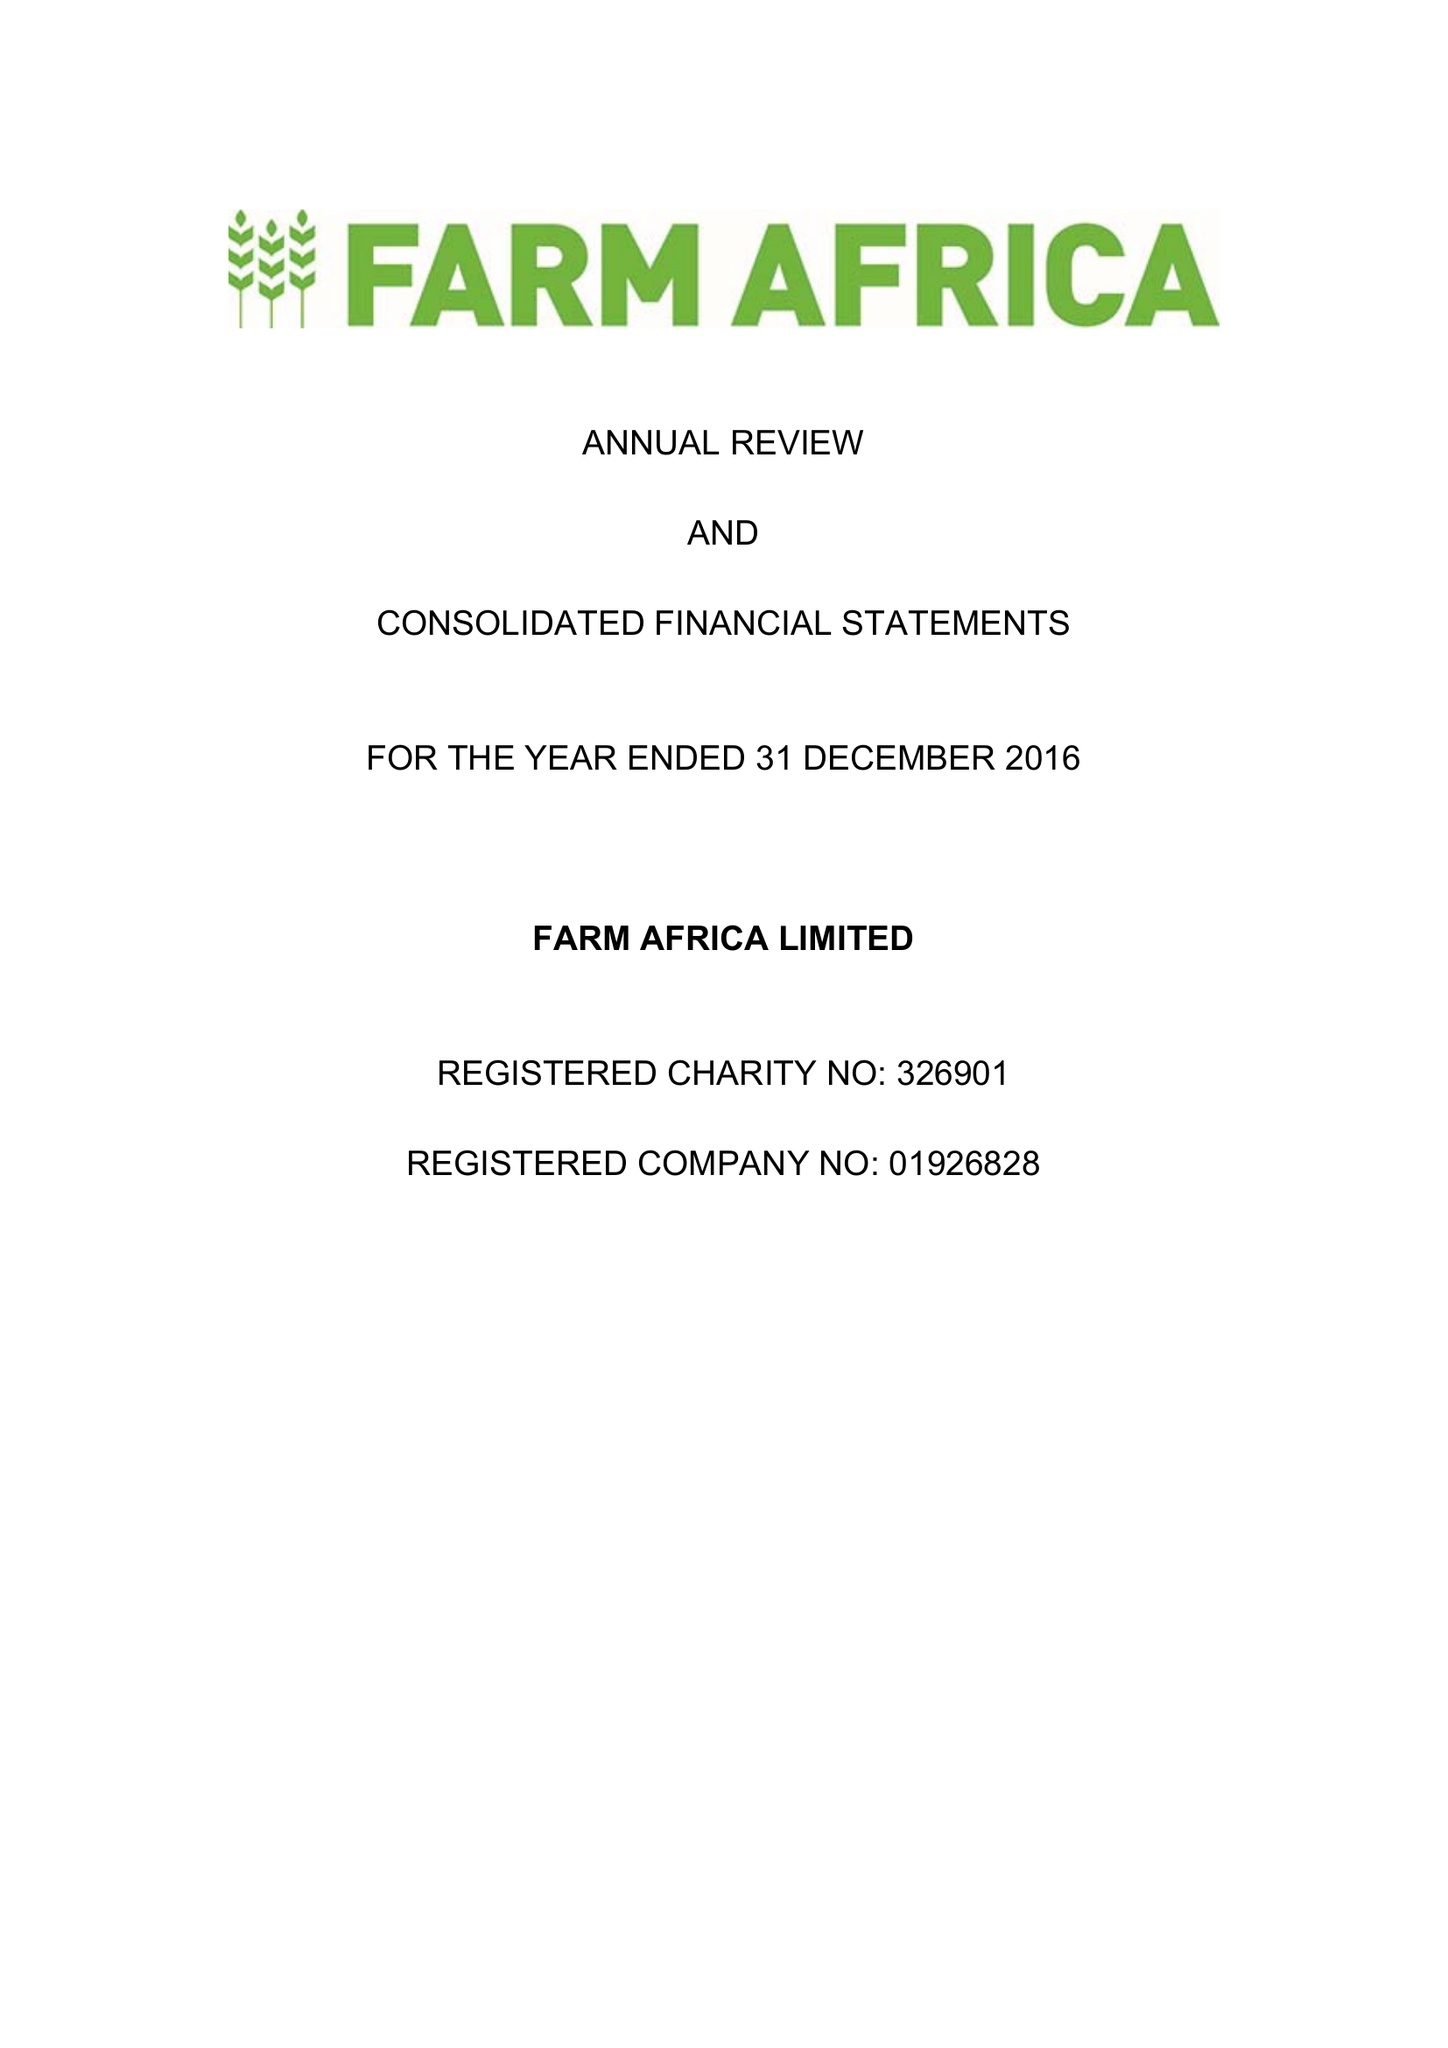What is the value for the charity_number?
Answer the question using a single word or phrase. 326901 